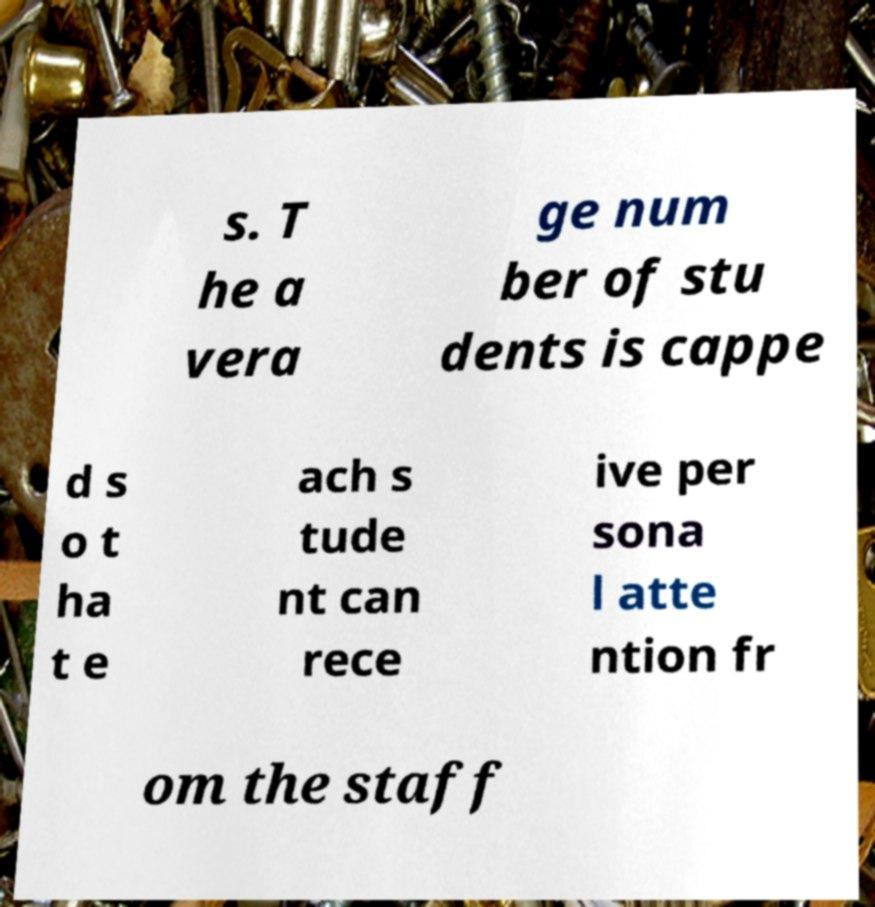I need the written content from this picture converted into text. Can you do that? s. T he a vera ge num ber of stu dents is cappe d s o t ha t e ach s tude nt can rece ive per sona l atte ntion fr om the staff 